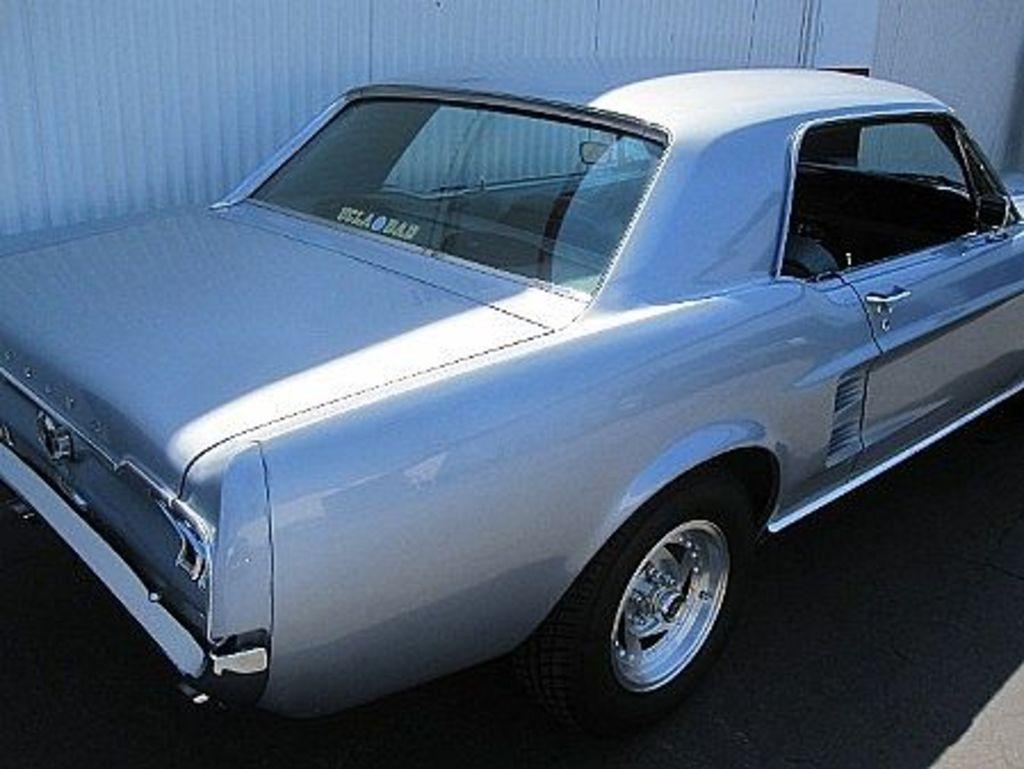Please provide a concise description of this image. In this image there is a car which is in the center. In the background there is a wall. 